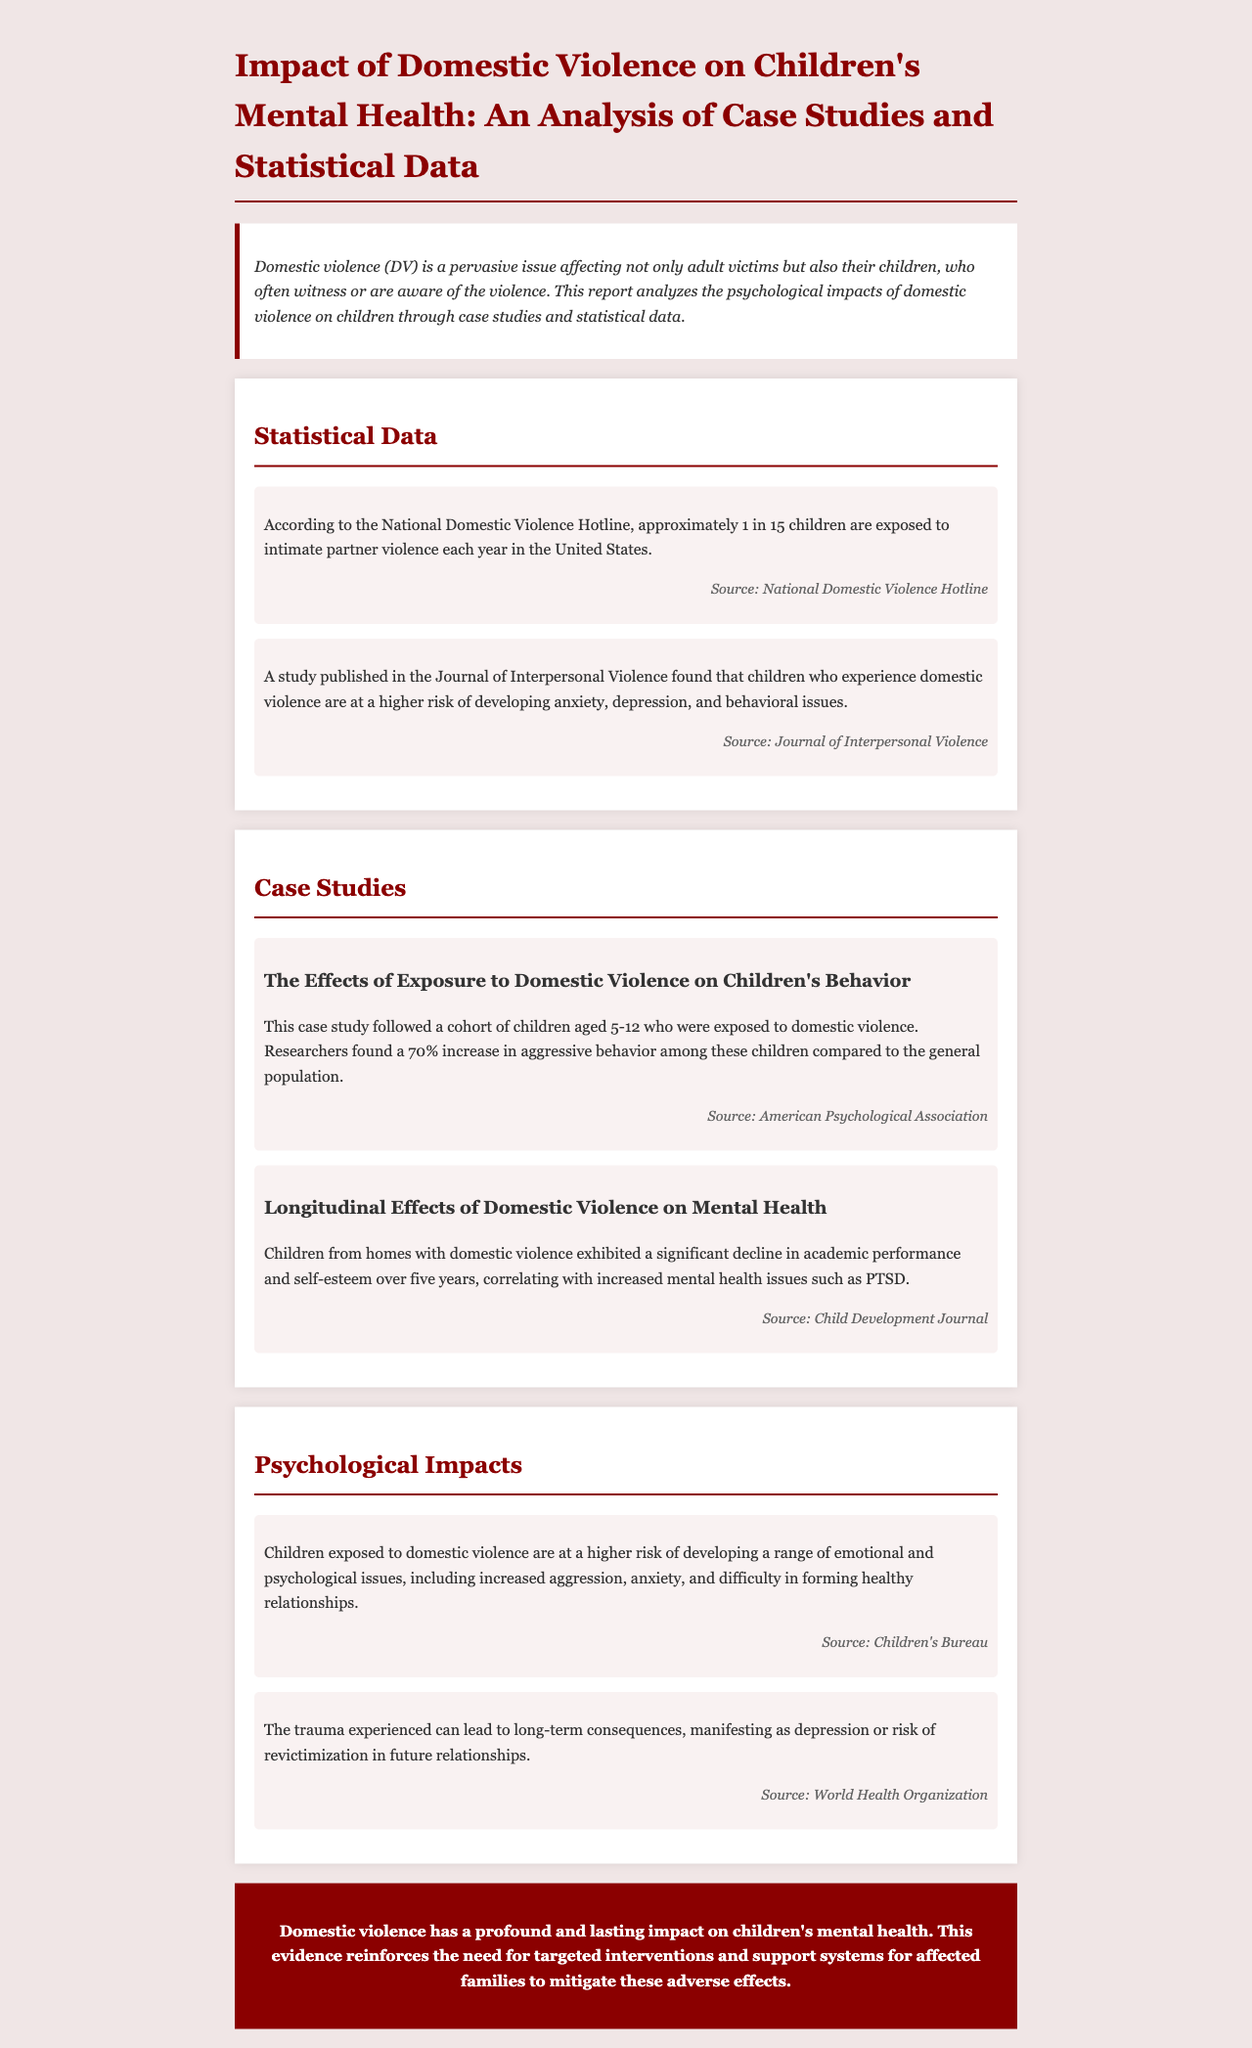what percentage of children showed increased aggressive behavior? The case study found a 70% increase in aggressive behavior among children exposed to domestic violence compared to the general population.
Answer: 70% how many children are exposed to intimate partner violence each year according to the National Domestic Violence Hotline? The report states that approximately 1 in 15 children are exposed to intimate partner violence each year in the United States.
Answer: 1 in 15 what psychological issues are children exposed to domestic violence at risk of developing? The document lists increased aggression, anxiety, and difficulty in forming healthy relationships among the psychological issues faced by children exposed to domestic violence.
Answer: increased aggression, anxiety, and difficulty in forming healthy relationships what long-term consequence can trauma from domestic violence lead to, according to the World Health Organization? The report mentions that the trauma experienced can lead to long-term consequences, manifesting as depression or risk of revictimization in future relationships.
Answer: depression or risk of revictimization which journal published a study about children experiencing domestic violence and their mental health risks? The study about children who experience domestic violence and their higher risk of mental health issues was published in the Journal of Interpersonal Violence.
Answer: Journal of Interpersonal Violence 